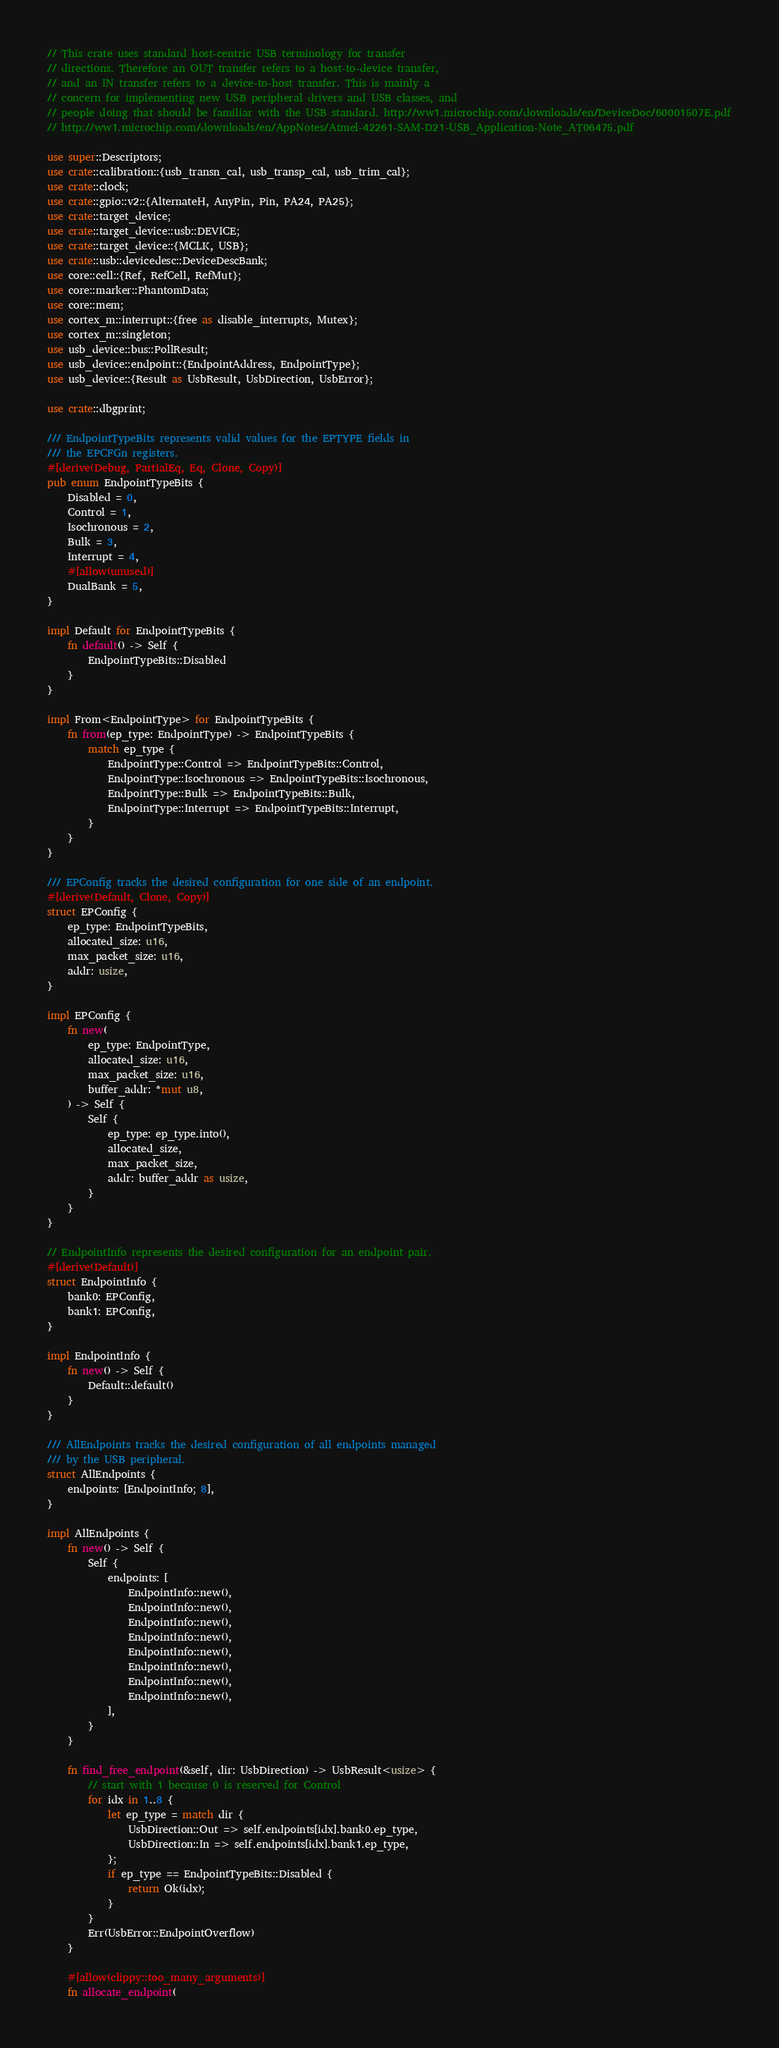<code> <loc_0><loc_0><loc_500><loc_500><_Rust_>// This crate uses standard host-centric USB terminology for transfer
// directions. Therefore an OUT transfer refers to a host-to-device transfer,
// and an IN transfer refers to a device-to-host transfer. This is mainly a
// concern for implementing new USB peripheral drivers and USB classes, and
// people doing that should be familiar with the USB standard. http://ww1.microchip.com/downloads/en/DeviceDoc/60001507E.pdf
// http://ww1.microchip.com/downloads/en/AppNotes/Atmel-42261-SAM-D21-USB_Application-Note_AT06475.pdf

use super::Descriptors;
use crate::calibration::{usb_transn_cal, usb_transp_cal, usb_trim_cal};
use crate::clock;
use crate::gpio::v2::{AlternateH, AnyPin, Pin, PA24, PA25};
use crate::target_device;
use crate::target_device::usb::DEVICE;
use crate::target_device::{MCLK, USB};
use crate::usb::devicedesc::DeviceDescBank;
use core::cell::{Ref, RefCell, RefMut};
use core::marker::PhantomData;
use core::mem;
use cortex_m::interrupt::{free as disable_interrupts, Mutex};
use cortex_m::singleton;
use usb_device::bus::PollResult;
use usb_device::endpoint::{EndpointAddress, EndpointType};
use usb_device::{Result as UsbResult, UsbDirection, UsbError};

use crate::dbgprint;

/// EndpointTypeBits represents valid values for the EPTYPE fields in
/// the EPCFGn registers.
#[derive(Debug, PartialEq, Eq, Clone, Copy)]
pub enum EndpointTypeBits {
    Disabled = 0,
    Control = 1,
    Isochronous = 2,
    Bulk = 3,
    Interrupt = 4,
    #[allow(unused)]
    DualBank = 5,
}

impl Default for EndpointTypeBits {
    fn default() -> Self {
        EndpointTypeBits::Disabled
    }
}

impl From<EndpointType> for EndpointTypeBits {
    fn from(ep_type: EndpointType) -> EndpointTypeBits {
        match ep_type {
            EndpointType::Control => EndpointTypeBits::Control,
            EndpointType::Isochronous => EndpointTypeBits::Isochronous,
            EndpointType::Bulk => EndpointTypeBits::Bulk,
            EndpointType::Interrupt => EndpointTypeBits::Interrupt,
        }
    }
}

/// EPConfig tracks the desired configuration for one side of an endpoint.
#[derive(Default, Clone, Copy)]
struct EPConfig {
    ep_type: EndpointTypeBits,
    allocated_size: u16,
    max_packet_size: u16,
    addr: usize,
}

impl EPConfig {
    fn new(
        ep_type: EndpointType,
        allocated_size: u16,
        max_packet_size: u16,
        buffer_addr: *mut u8,
    ) -> Self {
        Self {
            ep_type: ep_type.into(),
            allocated_size,
            max_packet_size,
            addr: buffer_addr as usize,
        }
    }
}

// EndpointInfo represents the desired configuration for an endpoint pair.
#[derive(Default)]
struct EndpointInfo {
    bank0: EPConfig,
    bank1: EPConfig,
}

impl EndpointInfo {
    fn new() -> Self {
        Default::default()
    }
}

/// AllEndpoints tracks the desired configuration of all endpoints managed
/// by the USB peripheral.
struct AllEndpoints {
    endpoints: [EndpointInfo; 8],
}

impl AllEndpoints {
    fn new() -> Self {
        Self {
            endpoints: [
                EndpointInfo::new(),
                EndpointInfo::new(),
                EndpointInfo::new(),
                EndpointInfo::new(),
                EndpointInfo::new(),
                EndpointInfo::new(),
                EndpointInfo::new(),
                EndpointInfo::new(),
            ],
        }
    }

    fn find_free_endpoint(&self, dir: UsbDirection) -> UsbResult<usize> {
        // start with 1 because 0 is reserved for Control
        for idx in 1..8 {
            let ep_type = match dir {
                UsbDirection::Out => self.endpoints[idx].bank0.ep_type,
                UsbDirection::In => self.endpoints[idx].bank1.ep_type,
            };
            if ep_type == EndpointTypeBits::Disabled {
                return Ok(idx);
            }
        }
        Err(UsbError::EndpointOverflow)
    }

    #[allow(clippy::too_many_arguments)]
    fn allocate_endpoint(</code> 